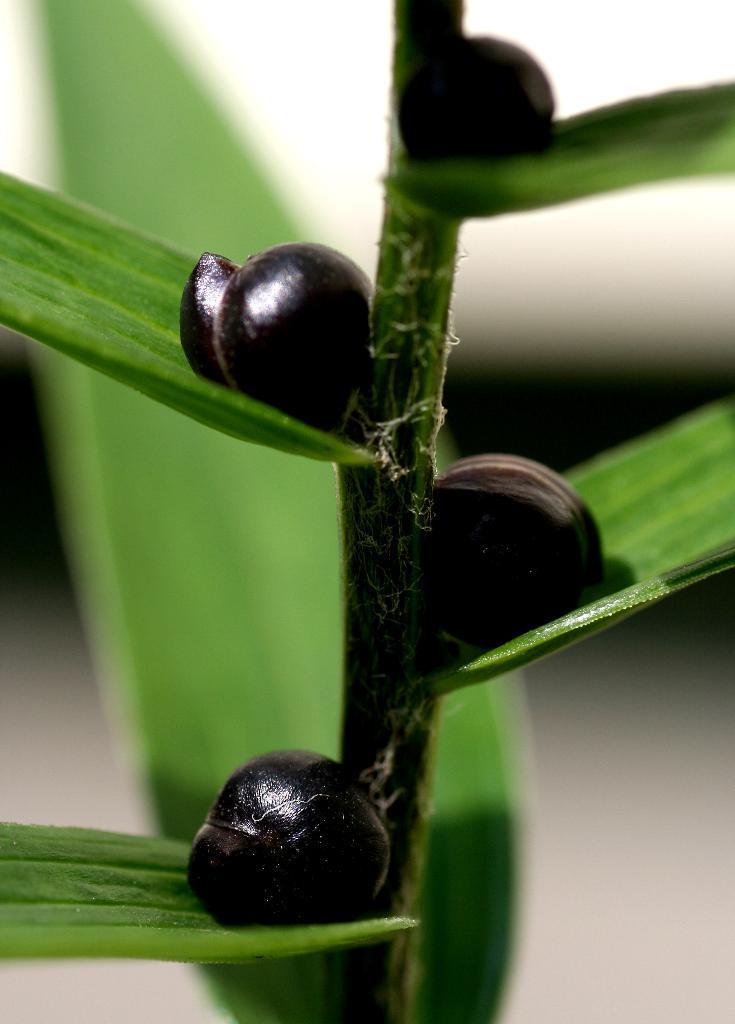Please provide a concise description of this image. As we can see in the image there is a plant and fruits. 